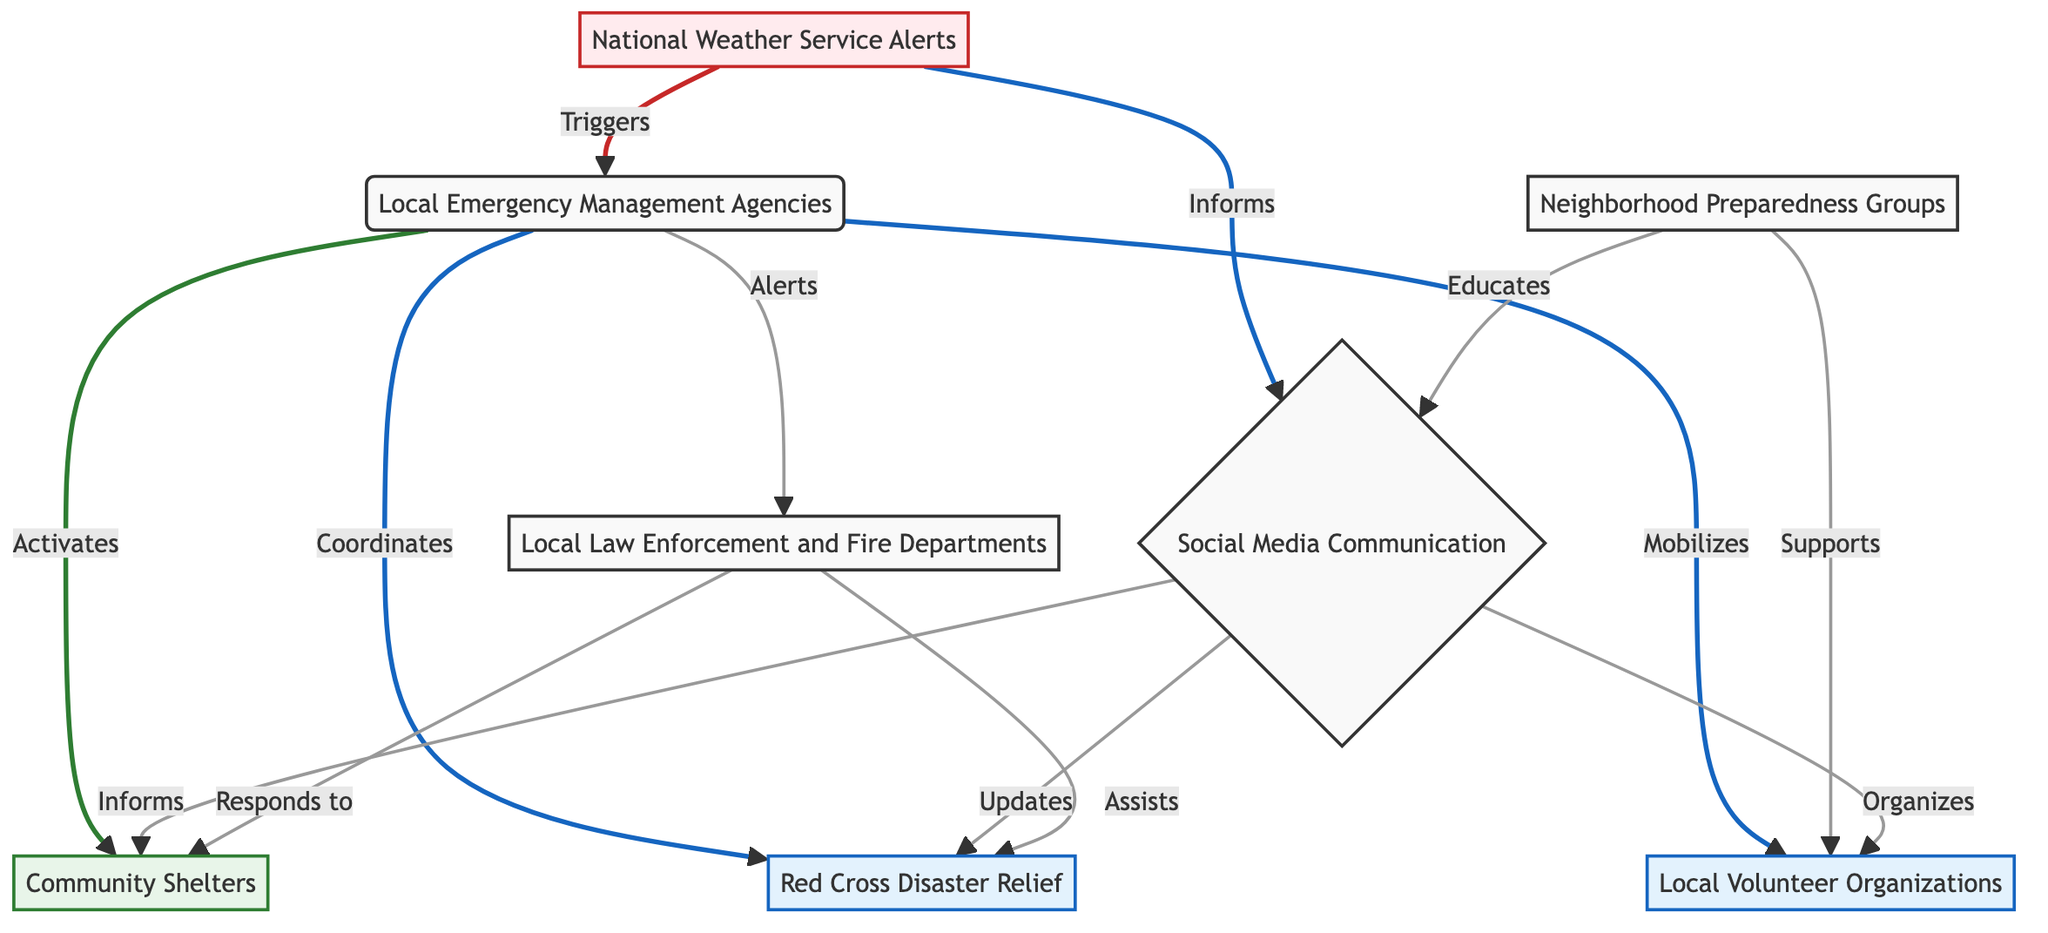What is the first step in the flow of community resources? The first step is the National Weather Service Alerts, which provides real-time notifications about severe weather warnings that trigger the next actions.
Answer: National Weather Service Alerts How many different nodes are there in the diagram? The diagram includes a total of 8 nodes representing various elements involved in the flow of community resources during extreme weather events.
Answer: 8 What does the Local Emergency Management Agencies do after receiving alerts? After receiving alerts, the Local Emergency Management Agencies activate Community Shelters, coordinate Red Cross Disaster Relief, mobilize Local Volunteer Organizations, and alert Local Law Enforcement and Fire Departments.
Answer: Activates, Coordinates, Mobilizes, Alerts Which two nodes are linked directly to Social Media Communication? The two nodes linked directly to Social Media Communication are Neighborhood Preparedness Groups and National Weather Service Alerts, indicating their role in informing the community.
Answer: Neighborhood Preparedness Groups, National Weather Service Alerts What support is provided at Community Shelters? Community Shelters provide safe places for residents to take refuge during tornadoes, ensuring their safety during extreme weather events.
Answer: Safe places for residents to take refuge How does Neighborhood Preparedness Groups support Local Volunteer Organizations? Neighborhood Preparedness Groups support Local Volunteer Organizations by mobilizing community members and enhancing training and awareness, ensuring an effective response during emergencies.
Answer: Supports Which organization responds alongside Local Law Enforcement to Community Shelters? The organization that responds alongside Local Law Enforcement to Community Shelters is the Red Cross Disaster Relief, assisting in providing emergency assistance and supplies.
Answer: Red Cross Disaster Relief What is the main purpose of Red Cross Disaster Relief? The main purpose of Red Cross Disaster Relief is to provide emergency assistance, food, and supplies to those affected by severe weather events.
Answer: Emergency assistance, food, and supplies How do Local Volunteer Organizations fit into the overall diagram? Local Volunteer Organizations are mobilized by Local Emergency Management Agencies and supported by Neighborhood Preparedness Groups, playing a critical role in community recovery after extreme weather events.
Answer: Mobilized and supported 